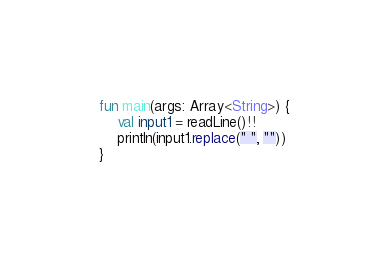Convert code to text. <code><loc_0><loc_0><loc_500><loc_500><_Kotlin_>fun main(args: Array<String>) {
    val input1 = readLine()!!
    println(input1.replace(" ", ""))
}
</code> 